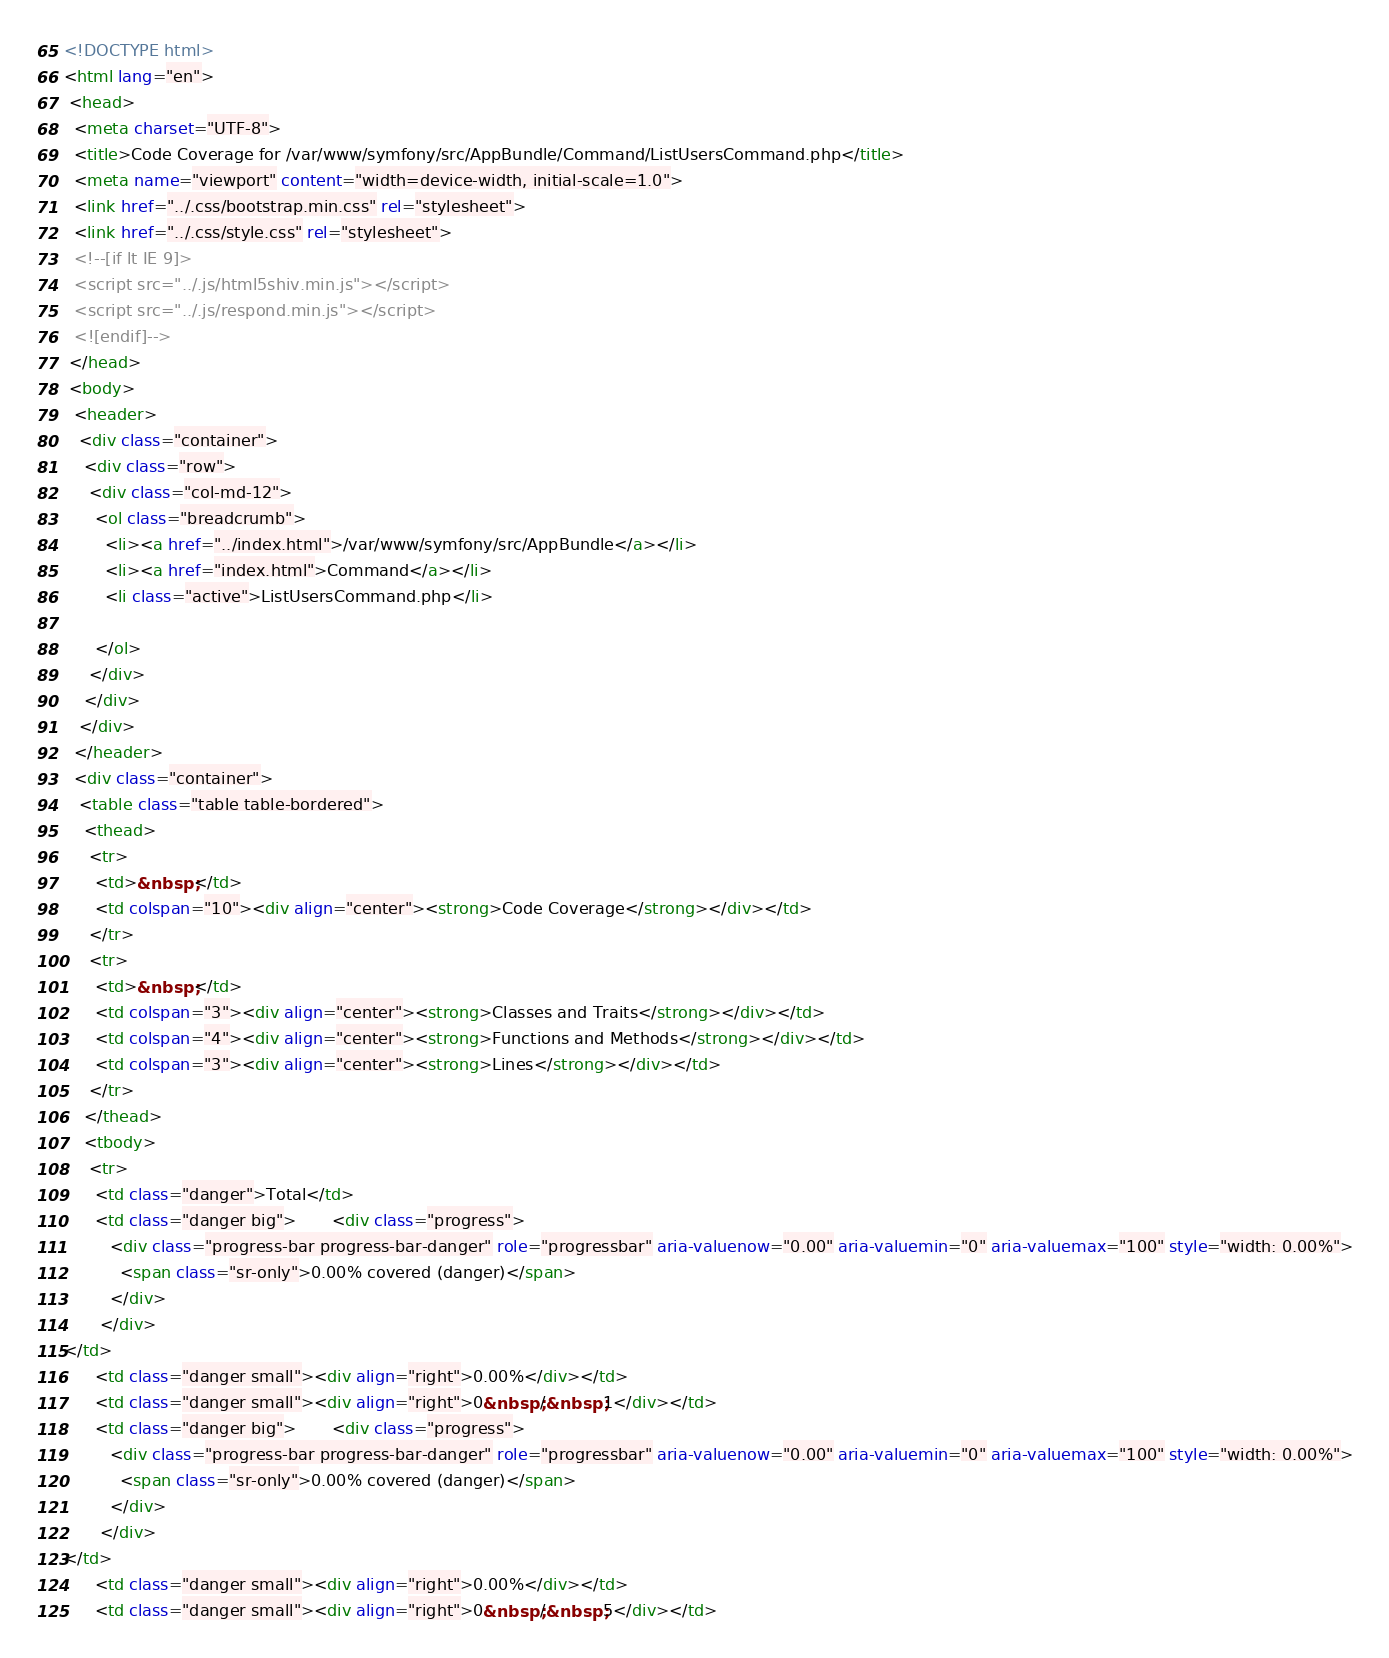<code> <loc_0><loc_0><loc_500><loc_500><_HTML_><!DOCTYPE html>
<html lang="en">
 <head>
  <meta charset="UTF-8">
  <title>Code Coverage for /var/www/symfony/src/AppBundle/Command/ListUsersCommand.php</title>
  <meta name="viewport" content="width=device-width, initial-scale=1.0">
  <link href="../.css/bootstrap.min.css" rel="stylesheet">
  <link href="../.css/style.css" rel="stylesheet">
  <!--[if lt IE 9]>
  <script src="../.js/html5shiv.min.js"></script>
  <script src="../.js/respond.min.js"></script>
  <![endif]-->
 </head>
 <body>
  <header>
   <div class="container">
    <div class="row">
     <div class="col-md-12">
      <ol class="breadcrumb">
        <li><a href="../index.html">/var/www/symfony/src/AppBundle</a></li>
        <li><a href="index.html">Command</a></li>
        <li class="active">ListUsersCommand.php</li>

      </ol>
     </div>
    </div>
   </div>
  </header>
  <div class="container">
   <table class="table table-bordered">
    <thead>
     <tr>
      <td>&nbsp;</td>
      <td colspan="10"><div align="center"><strong>Code Coverage</strong></div></td>
     </tr>
     <tr>
      <td>&nbsp;</td>
      <td colspan="3"><div align="center"><strong>Classes and Traits</strong></div></td>
      <td colspan="4"><div align="center"><strong>Functions and Methods</strong></div></td>
      <td colspan="3"><div align="center"><strong>Lines</strong></div></td>
     </tr>
    </thead>
    <tbody>
     <tr>
      <td class="danger">Total</td>
      <td class="danger big">       <div class="progress">
         <div class="progress-bar progress-bar-danger" role="progressbar" aria-valuenow="0.00" aria-valuemin="0" aria-valuemax="100" style="width: 0.00%">
           <span class="sr-only">0.00% covered (danger)</span>
         </div>
       </div>
</td>
      <td class="danger small"><div align="right">0.00%</div></td>
      <td class="danger small"><div align="right">0&nbsp;/&nbsp;1</div></td>
      <td class="danger big">       <div class="progress">
         <div class="progress-bar progress-bar-danger" role="progressbar" aria-valuenow="0.00" aria-valuemin="0" aria-valuemax="100" style="width: 0.00%">
           <span class="sr-only">0.00% covered (danger)</span>
         </div>
       </div>
</td>
      <td class="danger small"><div align="right">0.00%</div></td>
      <td class="danger small"><div align="right">0&nbsp;/&nbsp;5</div></td></code> 